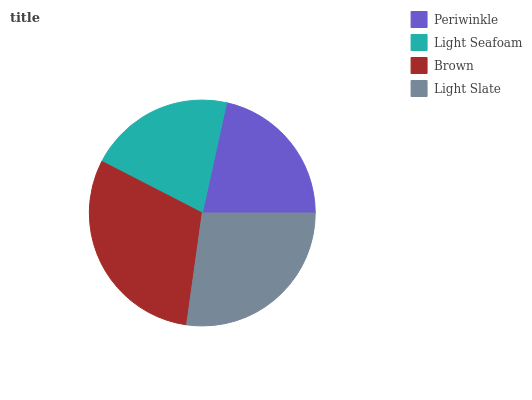Is Light Seafoam the minimum?
Answer yes or no. Yes. Is Brown the maximum?
Answer yes or no. Yes. Is Brown the minimum?
Answer yes or no. No. Is Light Seafoam the maximum?
Answer yes or no. No. Is Brown greater than Light Seafoam?
Answer yes or no. Yes. Is Light Seafoam less than Brown?
Answer yes or no. Yes. Is Light Seafoam greater than Brown?
Answer yes or no. No. Is Brown less than Light Seafoam?
Answer yes or no. No. Is Light Slate the high median?
Answer yes or no. Yes. Is Periwinkle the low median?
Answer yes or no. Yes. Is Brown the high median?
Answer yes or no. No. Is Brown the low median?
Answer yes or no. No. 